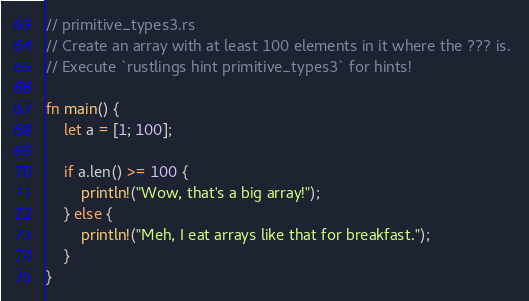<code> <loc_0><loc_0><loc_500><loc_500><_Rust_>// primitive_types3.rs
// Create an array with at least 100 elements in it where the ??? is. 
// Execute `rustlings hint primitive_types3` for hints!

fn main() {
    let a = [1; 100];

    if a.len() >= 100 {
        println!("Wow, that's a big array!");
    } else {
        println!("Meh, I eat arrays like that for breakfast.");
    }
}
</code> 